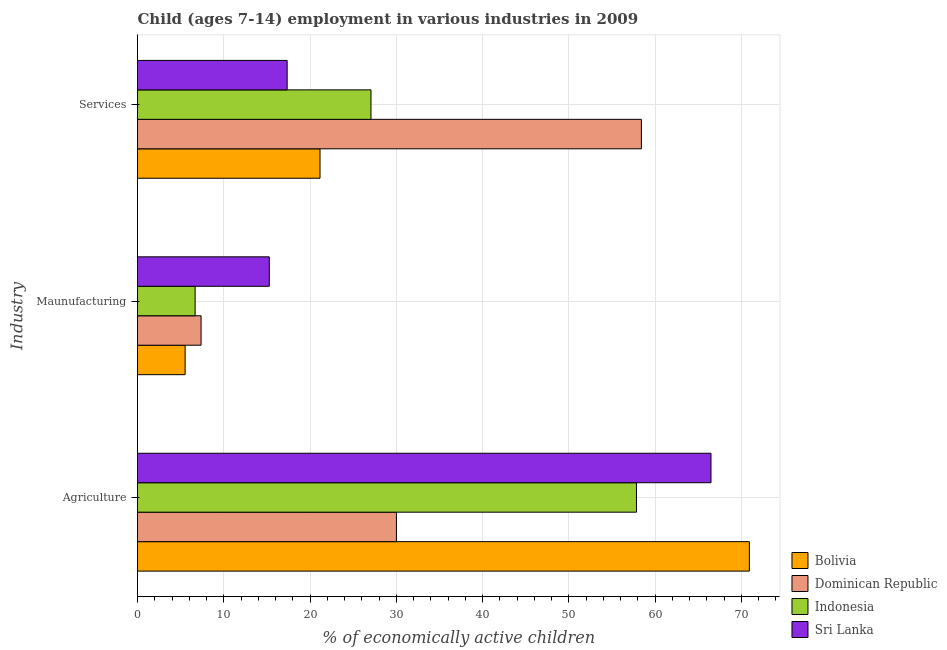How many different coloured bars are there?
Make the answer very short. 4. How many groups of bars are there?
Give a very brief answer. 3. How many bars are there on the 1st tick from the bottom?
Provide a short and direct response. 4. What is the label of the 3rd group of bars from the top?
Your answer should be compact. Agriculture. What is the percentage of economically active children in manufacturing in Bolivia?
Offer a very short reply. 5.52. Across all countries, what is the maximum percentage of economically active children in agriculture?
Give a very brief answer. 70.94. Across all countries, what is the minimum percentage of economically active children in agriculture?
Ensure brevity in your answer.  30.02. In which country was the percentage of economically active children in services maximum?
Your response must be concise. Dominican Republic. In which country was the percentage of economically active children in manufacturing minimum?
Your answer should be compact. Bolivia. What is the total percentage of economically active children in manufacturing in the graph?
Provide a short and direct response. 34.85. What is the difference between the percentage of economically active children in manufacturing in Bolivia and that in Indonesia?
Your answer should be very brief. -1.16. What is the difference between the percentage of economically active children in services in Sri Lanka and the percentage of economically active children in manufacturing in Dominican Republic?
Offer a very short reply. 9.98. What is the average percentage of economically active children in agriculture per country?
Offer a terse response. 56.33. What is the difference between the percentage of economically active children in agriculture and percentage of economically active children in services in Indonesia?
Provide a succinct answer. 30.78. In how many countries, is the percentage of economically active children in services greater than 22 %?
Your answer should be very brief. 2. What is the ratio of the percentage of economically active children in agriculture in Indonesia to that in Bolivia?
Give a very brief answer. 0.82. Is the difference between the percentage of economically active children in services in Bolivia and Sri Lanka greater than the difference between the percentage of economically active children in manufacturing in Bolivia and Sri Lanka?
Provide a short and direct response. Yes. What is the difference between the highest and the second highest percentage of economically active children in manufacturing?
Give a very brief answer. 7.91. What is the difference between the highest and the lowest percentage of economically active children in manufacturing?
Your answer should be very brief. 9.76. Is the sum of the percentage of economically active children in agriculture in Bolivia and Indonesia greater than the maximum percentage of economically active children in manufacturing across all countries?
Give a very brief answer. Yes. What does the 4th bar from the top in Services represents?
Make the answer very short. Bolivia. What does the 4th bar from the bottom in Agriculture represents?
Give a very brief answer. Sri Lanka. Are all the bars in the graph horizontal?
Offer a terse response. Yes. Does the graph contain any zero values?
Keep it short and to the point. No. Where does the legend appear in the graph?
Your answer should be compact. Bottom right. What is the title of the graph?
Give a very brief answer. Child (ages 7-14) employment in various industries in 2009. What is the label or title of the X-axis?
Keep it short and to the point. % of economically active children. What is the label or title of the Y-axis?
Your answer should be compact. Industry. What is the % of economically active children in Bolivia in Agriculture?
Offer a very short reply. 70.94. What is the % of economically active children of Dominican Republic in Agriculture?
Your answer should be compact. 30.02. What is the % of economically active children of Indonesia in Agriculture?
Make the answer very short. 57.85. What is the % of economically active children of Sri Lanka in Agriculture?
Your response must be concise. 66.49. What is the % of economically active children of Bolivia in Maunufacturing?
Make the answer very short. 5.52. What is the % of economically active children in Dominican Republic in Maunufacturing?
Keep it short and to the point. 7.37. What is the % of economically active children of Indonesia in Maunufacturing?
Offer a terse response. 6.68. What is the % of economically active children in Sri Lanka in Maunufacturing?
Your answer should be very brief. 15.28. What is the % of economically active children of Bolivia in Services?
Your response must be concise. 21.16. What is the % of economically active children in Dominican Republic in Services?
Ensure brevity in your answer.  58.42. What is the % of economically active children in Indonesia in Services?
Your response must be concise. 27.07. What is the % of economically active children in Sri Lanka in Services?
Offer a terse response. 17.35. Across all Industry, what is the maximum % of economically active children of Bolivia?
Your answer should be very brief. 70.94. Across all Industry, what is the maximum % of economically active children of Dominican Republic?
Make the answer very short. 58.42. Across all Industry, what is the maximum % of economically active children in Indonesia?
Keep it short and to the point. 57.85. Across all Industry, what is the maximum % of economically active children of Sri Lanka?
Offer a very short reply. 66.49. Across all Industry, what is the minimum % of economically active children in Bolivia?
Offer a very short reply. 5.52. Across all Industry, what is the minimum % of economically active children of Dominican Republic?
Ensure brevity in your answer.  7.37. Across all Industry, what is the minimum % of economically active children of Indonesia?
Provide a succinct answer. 6.68. Across all Industry, what is the minimum % of economically active children in Sri Lanka?
Your response must be concise. 15.28. What is the total % of economically active children in Bolivia in the graph?
Your answer should be compact. 97.62. What is the total % of economically active children in Dominican Republic in the graph?
Make the answer very short. 95.81. What is the total % of economically active children of Indonesia in the graph?
Provide a short and direct response. 91.6. What is the total % of economically active children of Sri Lanka in the graph?
Your answer should be very brief. 99.12. What is the difference between the % of economically active children of Bolivia in Agriculture and that in Maunufacturing?
Provide a succinct answer. 65.42. What is the difference between the % of economically active children in Dominican Republic in Agriculture and that in Maunufacturing?
Your answer should be compact. 22.65. What is the difference between the % of economically active children of Indonesia in Agriculture and that in Maunufacturing?
Provide a succinct answer. 51.17. What is the difference between the % of economically active children of Sri Lanka in Agriculture and that in Maunufacturing?
Keep it short and to the point. 51.21. What is the difference between the % of economically active children of Bolivia in Agriculture and that in Services?
Offer a very short reply. 49.78. What is the difference between the % of economically active children in Dominican Republic in Agriculture and that in Services?
Offer a very short reply. -28.4. What is the difference between the % of economically active children in Indonesia in Agriculture and that in Services?
Your answer should be compact. 30.78. What is the difference between the % of economically active children in Sri Lanka in Agriculture and that in Services?
Provide a succinct answer. 49.14. What is the difference between the % of economically active children of Bolivia in Maunufacturing and that in Services?
Your answer should be compact. -15.64. What is the difference between the % of economically active children in Dominican Republic in Maunufacturing and that in Services?
Offer a terse response. -51.05. What is the difference between the % of economically active children in Indonesia in Maunufacturing and that in Services?
Your answer should be very brief. -20.39. What is the difference between the % of economically active children in Sri Lanka in Maunufacturing and that in Services?
Make the answer very short. -2.07. What is the difference between the % of economically active children of Bolivia in Agriculture and the % of economically active children of Dominican Republic in Maunufacturing?
Offer a very short reply. 63.57. What is the difference between the % of economically active children of Bolivia in Agriculture and the % of economically active children of Indonesia in Maunufacturing?
Provide a short and direct response. 64.26. What is the difference between the % of economically active children of Bolivia in Agriculture and the % of economically active children of Sri Lanka in Maunufacturing?
Provide a short and direct response. 55.66. What is the difference between the % of economically active children in Dominican Republic in Agriculture and the % of economically active children in Indonesia in Maunufacturing?
Provide a short and direct response. 23.34. What is the difference between the % of economically active children of Dominican Republic in Agriculture and the % of economically active children of Sri Lanka in Maunufacturing?
Offer a very short reply. 14.74. What is the difference between the % of economically active children in Indonesia in Agriculture and the % of economically active children in Sri Lanka in Maunufacturing?
Provide a succinct answer. 42.57. What is the difference between the % of economically active children in Bolivia in Agriculture and the % of economically active children in Dominican Republic in Services?
Keep it short and to the point. 12.52. What is the difference between the % of economically active children of Bolivia in Agriculture and the % of economically active children of Indonesia in Services?
Give a very brief answer. 43.87. What is the difference between the % of economically active children of Bolivia in Agriculture and the % of economically active children of Sri Lanka in Services?
Provide a succinct answer. 53.59. What is the difference between the % of economically active children of Dominican Republic in Agriculture and the % of economically active children of Indonesia in Services?
Provide a short and direct response. 2.95. What is the difference between the % of economically active children in Dominican Republic in Agriculture and the % of economically active children in Sri Lanka in Services?
Make the answer very short. 12.67. What is the difference between the % of economically active children of Indonesia in Agriculture and the % of economically active children of Sri Lanka in Services?
Keep it short and to the point. 40.5. What is the difference between the % of economically active children of Bolivia in Maunufacturing and the % of economically active children of Dominican Republic in Services?
Offer a terse response. -52.9. What is the difference between the % of economically active children in Bolivia in Maunufacturing and the % of economically active children in Indonesia in Services?
Provide a short and direct response. -21.55. What is the difference between the % of economically active children of Bolivia in Maunufacturing and the % of economically active children of Sri Lanka in Services?
Ensure brevity in your answer.  -11.83. What is the difference between the % of economically active children in Dominican Republic in Maunufacturing and the % of economically active children in Indonesia in Services?
Keep it short and to the point. -19.7. What is the difference between the % of economically active children of Dominican Republic in Maunufacturing and the % of economically active children of Sri Lanka in Services?
Provide a short and direct response. -9.98. What is the difference between the % of economically active children of Indonesia in Maunufacturing and the % of economically active children of Sri Lanka in Services?
Your answer should be compact. -10.67. What is the average % of economically active children of Bolivia per Industry?
Keep it short and to the point. 32.54. What is the average % of economically active children of Dominican Republic per Industry?
Provide a short and direct response. 31.94. What is the average % of economically active children in Indonesia per Industry?
Keep it short and to the point. 30.53. What is the average % of economically active children in Sri Lanka per Industry?
Give a very brief answer. 33.04. What is the difference between the % of economically active children of Bolivia and % of economically active children of Dominican Republic in Agriculture?
Ensure brevity in your answer.  40.92. What is the difference between the % of economically active children in Bolivia and % of economically active children in Indonesia in Agriculture?
Provide a succinct answer. 13.09. What is the difference between the % of economically active children in Bolivia and % of economically active children in Sri Lanka in Agriculture?
Your answer should be compact. 4.45. What is the difference between the % of economically active children in Dominican Republic and % of economically active children in Indonesia in Agriculture?
Your answer should be compact. -27.83. What is the difference between the % of economically active children in Dominican Republic and % of economically active children in Sri Lanka in Agriculture?
Ensure brevity in your answer.  -36.47. What is the difference between the % of economically active children in Indonesia and % of economically active children in Sri Lanka in Agriculture?
Ensure brevity in your answer.  -8.64. What is the difference between the % of economically active children of Bolivia and % of economically active children of Dominican Republic in Maunufacturing?
Keep it short and to the point. -1.85. What is the difference between the % of economically active children in Bolivia and % of economically active children in Indonesia in Maunufacturing?
Provide a short and direct response. -1.16. What is the difference between the % of economically active children in Bolivia and % of economically active children in Sri Lanka in Maunufacturing?
Offer a terse response. -9.76. What is the difference between the % of economically active children of Dominican Republic and % of economically active children of Indonesia in Maunufacturing?
Give a very brief answer. 0.69. What is the difference between the % of economically active children of Dominican Republic and % of economically active children of Sri Lanka in Maunufacturing?
Offer a very short reply. -7.91. What is the difference between the % of economically active children in Indonesia and % of economically active children in Sri Lanka in Maunufacturing?
Provide a succinct answer. -8.6. What is the difference between the % of economically active children in Bolivia and % of economically active children in Dominican Republic in Services?
Your answer should be very brief. -37.26. What is the difference between the % of economically active children in Bolivia and % of economically active children in Indonesia in Services?
Keep it short and to the point. -5.91. What is the difference between the % of economically active children in Bolivia and % of economically active children in Sri Lanka in Services?
Make the answer very short. 3.81. What is the difference between the % of economically active children in Dominican Republic and % of economically active children in Indonesia in Services?
Offer a very short reply. 31.35. What is the difference between the % of economically active children of Dominican Republic and % of economically active children of Sri Lanka in Services?
Your answer should be very brief. 41.07. What is the difference between the % of economically active children in Indonesia and % of economically active children in Sri Lanka in Services?
Provide a succinct answer. 9.72. What is the ratio of the % of economically active children of Bolivia in Agriculture to that in Maunufacturing?
Ensure brevity in your answer.  12.85. What is the ratio of the % of economically active children of Dominican Republic in Agriculture to that in Maunufacturing?
Your response must be concise. 4.07. What is the ratio of the % of economically active children in Indonesia in Agriculture to that in Maunufacturing?
Your response must be concise. 8.66. What is the ratio of the % of economically active children in Sri Lanka in Agriculture to that in Maunufacturing?
Make the answer very short. 4.35. What is the ratio of the % of economically active children in Bolivia in Agriculture to that in Services?
Make the answer very short. 3.35. What is the ratio of the % of economically active children of Dominican Republic in Agriculture to that in Services?
Offer a terse response. 0.51. What is the ratio of the % of economically active children of Indonesia in Agriculture to that in Services?
Provide a short and direct response. 2.14. What is the ratio of the % of economically active children of Sri Lanka in Agriculture to that in Services?
Ensure brevity in your answer.  3.83. What is the ratio of the % of economically active children of Bolivia in Maunufacturing to that in Services?
Offer a very short reply. 0.26. What is the ratio of the % of economically active children in Dominican Republic in Maunufacturing to that in Services?
Your response must be concise. 0.13. What is the ratio of the % of economically active children of Indonesia in Maunufacturing to that in Services?
Your answer should be very brief. 0.25. What is the ratio of the % of economically active children in Sri Lanka in Maunufacturing to that in Services?
Make the answer very short. 0.88. What is the difference between the highest and the second highest % of economically active children in Bolivia?
Offer a terse response. 49.78. What is the difference between the highest and the second highest % of economically active children of Dominican Republic?
Give a very brief answer. 28.4. What is the difference between the highest and the second highest % of economically active children of Indonesia?
Make the answer very short. 30.78. What is the difference between the highest and the second highest % of economically active children in Sri Lanka?
Your response must be concise. 49.14. What is the difference between the highest and the lowest % of economically active children in Bolivia?
Provide a succinct answer. 65.42. What is the difference between the highest and the lowest % of economically active children of Dominican Republic?
Make the answer very short. 51.05. What is the difference between the highest and the lowest % of economically active children in Indonesia?
Ensure brevity in your answer.  51.17. What is the difference between the highest and the lowest % of economically active children of Sri Lanka?
Keep it short and to the point. 51.21. 